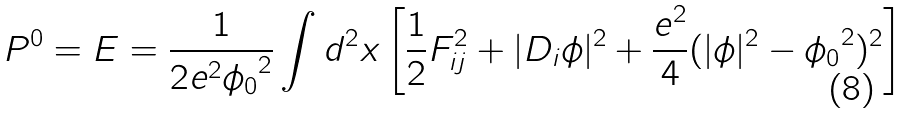Convert formula to latex. <formula><loc_0><loc_0><loc_500><loc_500>P ^ { 0 } = E = \frac { 1 } { 2 e ^ { 2 } { \phi _ { 0 } } ^ { 2 } } \int d ^ { 2 } x \left [ \frac { 1 } { 2 } F _ { i j } ^ { 2 } + | D _ { i } \phi | ^ { 2 } + \frac { e ^ { 2 } } { 4 } ( | \phi | ^ { 2 } - { \phi _ { 0 } } ^ { 2 } ) ^ { 2 } \right ]</formula> 